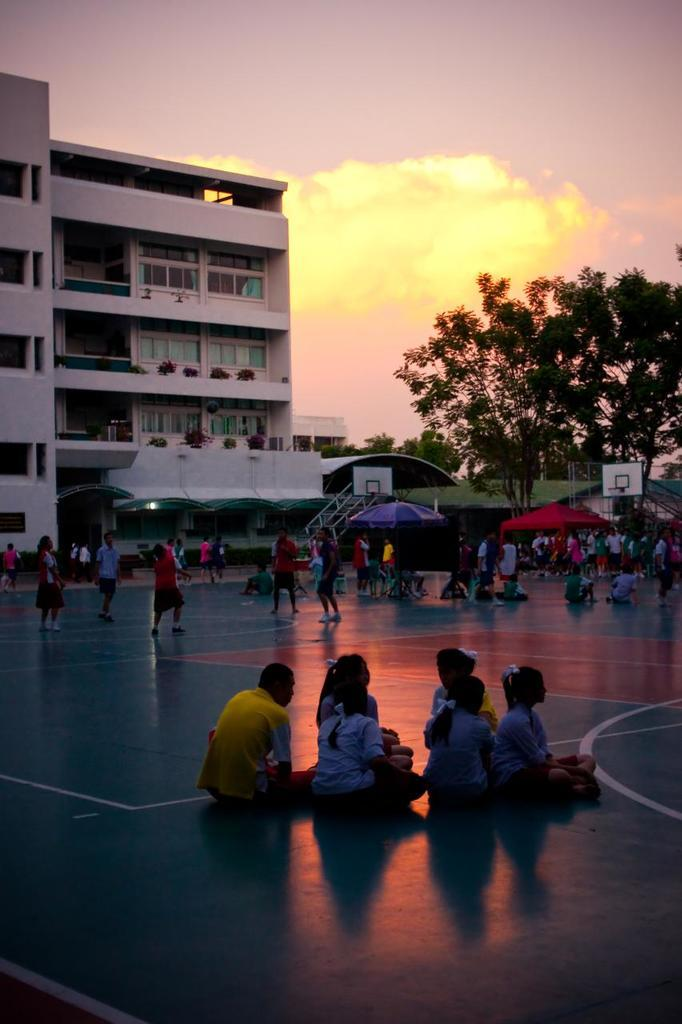What are the children in the image doing? Some children are standing on the floor, while others are sitting on the floor. What can be seen in the background of the image? There are parasols, sheds, buildings, trees, and the sky with clouds visible in the background. How many types of structures can be seen in the background? There are three types of structures visible in the background: sheds, buildings, and parasols. What type of nerve can be seen affecting the children's movements in the image? There is no nerve present in the image, and the children's movements are not affected by any nerve. Is there any quicksand visible in the image? There is no quicksand present in the image. 